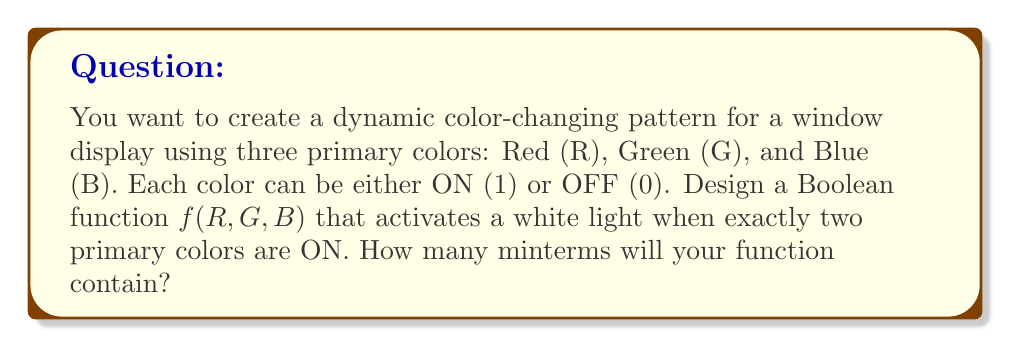Give your solution to this math problem. Let's approach this step-by-step:

1) First, we need to understand what minterms are. In Boolean algebra, a minterm is a product term in which each variable appears exactly once, either in its true or complemented form.

2) We have 3 variables: R, G, and B. Each can be either 0 or 1, giving us $2^3 = 8$ possible combinations.

3) We want the function to be true (1) when exactly two colors are ON. Let's list all possible combinations:

   $$(R,G,B) = (1,1,0), (1,0,1), (0,1,1)$$

4) Now, let's write the Boolean function for each of these:

   $$f(R,G,B) = R \cdot G \cdot \overline{B} + R \cdot \overline{G} \cdot B + \overline{R} \cdot G \cdot B$$

5) Each term in this sum $(R \cdot G \cdot \overline{B})$, $(R \cdot \overline{G} \cdot B)$, and $(\overline{R} \cdot G \cdot B)$ is a minterm.

6) Count the number of minterms in the function. There are 3 minterms.
Answer: 3 